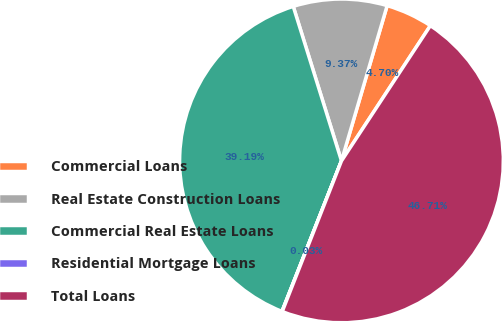Convert chart to OTSL. <chart><loc_0><loc_0><loc_500><loc_500><pie_chart><fcel>Commercial Loans<fcel>Real Estate Construction Loans<fcel>Commercial Real Estate Loans<fcel>Residential Mortgage Loans<fcel>Total Loans<nl><fcel>4.7%<fcel>9.37%<fcel>39.19%<fcel>0.03%<fcel>46.71%<nl></chart> 